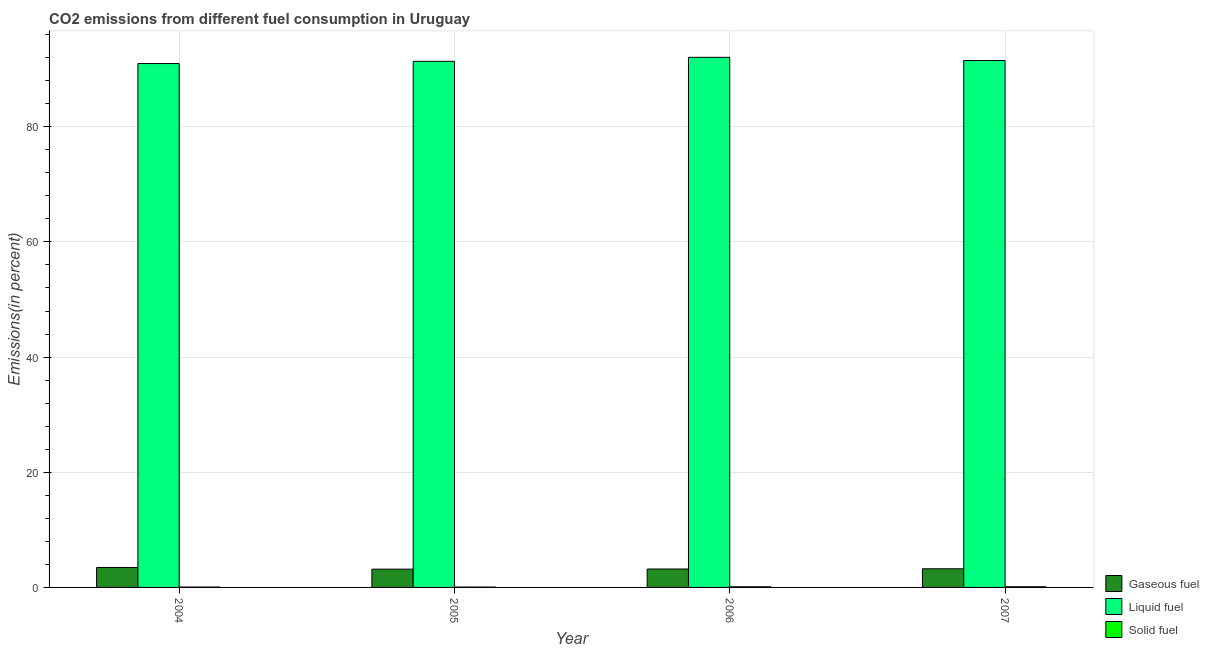How many groups of bars are there?
Offer a very short reply. 4. Are the number of bars per tick equal to the number of legend labels?
Offer a very short reply. Yes. Are the number of bars on each tick of the X-axis equal?
Provide a short and direct response. Yes. How many bars are there on the 1st tick from the right?
Provide a short and direct response. 3. What is the label of the 2nd group of bars from the left?
Your answer should be compact. 2005. In how many cases, is the number of bars for a given year not equal to the number of legend labels?
Offer a very short reply. 0. What is the percentage of gaseous fuel emission in 2007?
Provide a succinct answer. 3.24. Across all years, what is the maximum percentage of solid fuel emission?
Your response must be concise. 0.12. Across all years, what is the minimum percentage of gaseous fuel emission?
Offer a terse response. 3.17. In which year was the percentage of solid fuel emission minimum?
Your response must be concise. 2005. What is the total percentage of solid fuel emission in the graph?
Offer a terse response. 0.36. What is the difference between the percentage of gaseous fuel emission in 2004 and that in 2005?
Provide a succinct answer. 0.29. What is the difference between the percentage of gaseous fuel emission in 2007 and the percentage of solid fuel emission in 2006?
Keep it short and to the point. 0.04. What is the average percentage of liquid fuel emission per year?
Keep it short and to the point. 91.48. In how many years, is the percentage of liquid fuel emission greater than 20 %?
Offer a terse response. 4. What is the ratio of the percentage of liquid fuel emission in 2004 to that in 2006?
Keep it short and to the point. 0.99. Is the percentage of liquid fuel emission in 2004 less than that in 2005?
Offer a very short reply. Yes. Is the difference between the percentage of solid fuel emission in 2005 and 2006 greater than the difference between the percentage of gaseous fuel emission in 2005 and 2006?
Provide a succinct answer. No. What is the difference between the highest and the second highest percentage of gaseous fuel emission?
Your answer should be very brief. 0.22. What is the difference between the highest and the lowest percentage of liquid fuel emission?
Your answer should be compact. 1.08. In how many years, is the percentage of liquid fuel emission greater than the average percentage of liquid fuel emission taken over all years?
Provide a succinct answer. 2. What does the 2nd bar from the left in 2006 represents?
Provide a short and direct response. Liquid fuel. What does the 2nd bar from the right in 2007 represents?
Your answer should be compact. Liquid fuel. Is it the case that in every year, the sum of the percentage of gaseous fuel emission and percentage of liquid fuel emission is greater than the percentage of solid fuel emission?
Ensure brevity in your answer.  Yes. Are all the bars in the graph horizontal?
Offer a terse response. No. Are the values on the major ticks of Y-axis written in scientific E-notation?
Your answer should be very brief. No. Where does the legend appear in the graph?
Give a very brief answer. Bottom right. How many legend labels are there?
Your response must be concise. 3. What is the title of the graph?
Make the answer very short. CO2 emissions from different fuel consumption in Uruguay. Does "Ores and metals" appear as one of the legend labels in the graph?
Give a very brief answer. No. What is the label or title of the Y-axis?
Offer a terse response. Emissions(in percent). What is the Emissions(in percent) in Gaseous fuel in 2004?
Ensure brevity in your answer.  3.46. What is the Emissions(in percent) of Liquid fuel in 2004?
Provide a short and direct response. 90.98. What is the Emissions(in percent) in Solid fuel in 2004?
Make the answer very short. 0.07. What is the Emissions(in percent) of Gaseous fuel in 2005?
Provide a succinct answer. 3.17. What is the Emissions(in percent) of Liquid fuel in 2005?
Give a very brief answer. 91.37. What is the Emissions(in percent) in Solid fuel in 2005?
Give a very brief answer. 0.06. What is the Emissions(in percent) of Gaseous fuel in 2006?
Your answer should be compact. 3.2. What is the Emissions(in percent) in Liquid fuel in 2006?
Provide a short and direct response. 92.06. What is the Emissions(in percent) in Solid fuel in 2006?
Your response must be concise. 0.11. What is the Emissions(in percent) of Gaseous fuel in 2007?
Your response must be concise. 3.24. What is the Emissions(in percent) in Liquid fuel in 2007?
Ensure brevity in your answer.  91.5. What is the Emissions(in percent) of Solid fuel in 2007?
Offer a very short reply. 0.12. Across all years, what is the maximum Emissions(in percent) in Gaseous fuel?
Your answer should be compact. 3.46. Across all years, what is the maximum Emissions(in percent) of Liquid fuel?
Ensure brevity in your answer.  92.06. Across all years, what is the maximum Emissions(in percent) in Solid fuel?
Ensure brevity in your answer.  0.12. Across all years, what is the minimum Emissions(in percent) in Gaseous fuel?
Provide a short and direct response. 3.17. Across all years, what is the minimum Emissions(in percent) of Liquid fuel?
Provide a short and direct response. 90.98. Across all years, what is the minimum Emissions(in percent) of Solid fuel?
Provide a succinct answer. 0.06. What is the total Emissions(in percent) of Gaseous fuel in the graph?
Provide a succinct answer. 13.08. What is the total Emissions(in percent) in Liquid fuel in the graph?
Make the answer very short. 365.91. What is the total Emissions(in percent) in Solid fuel in the graph?
Your answer should be very brief. 0.36. What is the difference between the Emissions(in percent) of Gaseous fuel in 2004 and that in 2005?
Offer a very short reply. 0.29. What is the difference between the Emissions(in percent) of Liquid fuel in 2004 and that in 2005?
Provide a short and direct response. -0.38. What is the difference between the Emissions(in percent) in Solid fuel in 2004 and that in 2005?
Provide a succinct answer. 0. What is the difference between the Emissions(in percent) of Gaseous fuel in 2004 and that in 2006?
Ensure brevity in your answer.  0.26. What is the difference between the Emissions(in percent) of Liquid fuel in 2004 and that in 2006?
Make the answer very short. -1.08. What is the difference between the Emissions(in percent) in Solid fuel in 2004 and that in 2006?
Make the answer very short. -0.04. What is the difference between the Emissions(in percent) of Gaseous fuel in 2004 and that in 2007?
Offer a very short reply. 0.22. What is the difference between the Emissions(in percent) in Liquid fuel in 2004 and that in 2007?
Provide a short and direct response. -0.52. What is the difference between the Emissions(in percent) of Solid fuel in 2004 and that in 2007?
Your answer should be very brief. -0.06. What is the difference between the Emissions(in percent) of Gaseous fuel in 2005 and that in 2006?
Make the answer very short. -0.02. What is the difference between the Emissions(in percent) of Liquid fuel in 2005 and that in 2006?
Your answer should be compact. -0.69. What is the difference between the Emissions(in percent) in Solid fuel in 2005 and that in 2006?
Your answer should be compact. -0.05. What is the difference between the Emissions(in percent) in Gaseous fuel in 2005 and that in 2007?
Ensure brevity in your answer.  -0.07. What is the difference between the Emissions(in percent) in Liquid fuel in 2005 and that in 2007?
Your response must be concise. -0.14. What is the difference between the Emissions(in percent) in Solid fuel in 2005 and that in 2007?
Ensure brevity in your answer.  -0.06. What is the difference between the Emissions(in percent) in Gaseous fuel in 2006 and that in 2007?
Provide a short and direct response. -0.04. What is the difference between the Emissions(in percent) of Liquid fuel in 2006 and that in 2007?
Give a very brief answer. 0.55. What is the difference between the Emissions(in percent) of Solid fuel in 2006 and that in 2007?
Make the answer very short. -0.01. What is the difference between the Emissions(in percent) of Gaseous fuel in 2004 and the Emissions(in percent) of Liquid fuel in 2005?
Provide a short and direct response. -87.9. What is the difference between the Emissions(in percent) in Gaseous fuel in 2004 and the Emissions(in percent) in Solid fuel in 2005?
Give a very brief answer. 3.4. What is the difference between the Emissions(in percent) in Liquid fuel in 2004 and the Emissions(in percent) in Solid fuel in 2005?
Offer a very short reply. 90.92. What is the difference between the Emissions(in percent) in Gaseous fuel in 2004 and the Emissions(in percent) in Liquid fuel in 2006?
Your response must be concise. -88.59. What is the difference between the Emissions(in percent) of Gaseous fuel in 2004 and the Emissions(in percent) of Solid fuel in 2006?
Give a very brief answer. 3.35. What is the difference between the Emissions(in percent) in Liquid fuel in 2004 and the Emissions(in percent) in Solid fuel in 2006?
Give a very brief answer. 90.87. What is the difference between the Emissions(in percent) in Gaseous fuel in 2004 and the Emissions(in percent) in Liquid fuel in 2007?
Provide a succinct answer. -88.04. What is the difference between the Emissions(in percent) in Gaseous fuel in 2004 and the Emissions(in percent) in Solid fuel in 2007?
Provide a succinct answer. 3.34. What is the difference between the Emissions(in percent) in Liquid fuel in 2004 and the Emissions(in percent) in Solid fuel in 2007?
Provide a succinct answer. 90.86. What is the difference between the Emissions(in percent) of Gaseous fuel in 2005 and the Emissions(in percent) of Liquid fuel in 2006?
Ensure brevity in your answer.  -88.88. What is the difference between the Emissions(in percent) of Gaseous fuel in 2005 and the Emissions(in percent) of Solid fuel in 2006?
Offer a terse response. 3.06. What is the difference between the Emissions(in percent) in Liquid fuel in 2005 and the Emissions(in percent) in Solid fuel in 2006?
Keep it short and to the point. 91.25. What is the difference between the Emissions(in percent) in Gaseous fuel in 2005 and the Emissions(in percent) in Liquid fuel in 2007?
Your answer should be compact. -88.33. What is the difference between the Emissions(in percent) of Gaseous fuel in 2005 and the Emissions(in percent) of Solid fuel in 2007?
Offer a terse response. 3.05. What is the difference between the Emissions(in percent) of Liquid fuel in 2005 and the Emissions(in percent) of Solid fuel in 2007?
Your response must be concise. 91.24. What is the difference between the Emissions(in percent) of Gaseous fuel in 2006 and the Emissions(in percent) of Liquid fuel in 2007?
Make the answer very short. -88.3. What is the difference between the Emissions(in percent) in Gaseous fuel in 2006 and the Emissions(in percent) in Solid fuel in 2007?
Your response must be concise. 3.08. What is the difference between the Emissions(in percent) of Liquid fuel in 2006 and the Emissions(in percent) of Solid fuel in 2007?
Your response must be concise. 91.94. What is the average Emissions(in percent) in Gaseous fuel per year?
Offer a very short reply. 3.27. What is the average Emissions(in percent) of Liquid fuel per year?
Ensure brevity in your answer.  91.48. What is the average Emissions(in percent) of Solid fuel per year?
Give a very brief answer. 0.09. In the year 2004, what is the difference between the Emissions(in percent) of Gaseous fuel and Emissions(in percent) of Liquid fuel?
Offer a terse response. -87.52. In the year 2004, what is the difference between the Emissions(in percent) of Gaseous fuel and Emissions(in percent) of Solid fuel?
Offer a very short reply. 3.4. In the year 2004, what is the difference between the Emissions(in percent) in Liquid fuel and Emissions(in percent) in Solid fuel?
Give a very brief answer. 90.92. In the year 2005, what is the difference between the Emissions(in percent) in Gaseous fuel and Emissions(in percent) in Liquid fuel?
Provide a succinct answer. -88.19. In the year 2005, what is the difference between the Emissions(in percent) of Gaseous fuel and Emissions(in percent) of Solid fuel?
Your answer should be very brief. 3.11. In the year 2005, what is the difference between the Emissions(in percent) in Liquid fuel and Emissions(in percent) in Solid fuel?
Your answer should be compact. 91.3. In the year 2006, what is the difference between the Emissions(in percent) of Gaseous fuel and Emissions(in percent) of Liquid fuel?
Offer a very short reply. -88.86. In the year 2006, what is the difference between the Emissions(in percent) of Gaseous fuel and Emissions(in percent) of Solid fuel?
Make the answer very short. 3.09. In the year 2006, what is the difference between the Emissions(in percent) of Liquid fuel and Emissions(in percent) of Solid fuel?
Keep it short and to the point. 91.95. In the year 2007, what is the difference between the Emissions(in percent) in Gaseous fuel and Emissions(in percent) in Liquid fuel?
Offer a terse response. -88.26. In the year 2007, what is the difference between the Emissions(in percent) in Gaseous fuel and Emissions(in percent) in Solid fuel?
Keep it short and to the point. 3.12. In the year 2007, what is the difference between the Emissions(in percent) in Liquid fuel and Emissions(in percent) in Solid fuel?
Make the answer very short. 91.38. What is the ratio of the Emissions(in percent) of Gaseous fuel in 2004 to that in 2005?
Offer a terse response. 1.09. What is the ratio of the Emissions(in percent) of Liquid fuel in 2004 to that in 2005?
Give a very brief answer. 1. What is the ratio of the Emissions(in percent) of Solid fuel in 2004 to that in 2005?
Your response must be concise. 1.03. What is the ratio of the Emissions(in percent) of Gaseous fuel in 2004 to that in 2006?
Offer a terse response. 1.08. What is the ratio of the Emissions(in percent) of Liquid fuel in 2004 to that in 2006?
Provide a succinct answer. 0.99. What is the ratio of the Emissions(in percent) of Solid fuel in 2004 to that in 2006?
Ensure brevity in your answer.  0.59. What is the ratio of the Emissions(in percent) in Gaseous fuel in 2004 to that in 2007?
Keep it short and to the point. 1.07. What is the ratio of the Emissions(in percent) in Solid fuel in 2004 to that in 2007?
Offer a very short reply. 0.53. What is the ratio of the Emissions(in percent) of Gaseous fuel in 2005 to that in 2006?
Offer a very short reply. 0.99. What is the ratio of the Emissions(in percent) of Solid fuel in 2005 to that in 2006?
Offer a very short reply. 0.58. What is the ratio of the Emissions(in percent) in Gaseous fuel in 2005 to that in 2007?
Keep it short and to the point. 0.98. What is the ratio of the Emissions(in percent) of Solid fuel in 2005 to that in 2007?
Provide a short and direct response. 0.52. What is the ratio of the Emissions(in percent) in Gaseous fuel in 2006 to that in 2007?
Offer a very short reply. 0.99. What is the ratio of the Emissions(in percent) of Liquid fuel in 2006 to that in 2007?
Your answer should be compact. 1.01. What is the ratio of the Emissions(in percent) of Solid fuel in 2006 to that in 2007?
Offer a very short reply. 0.9. What is the difference between the highest and the second highest Emissions(in percent) of Gaseous fuel?
Your answer should be very brief. 0.22. What is the difference between the highest and the second highest Emissions(in percent) in Liquid fuel?
Your answer should be compact. 0.55. What is the difference between the highest and the second highest Emissions(in percent) in Solid fuel?
Provide a short and direct response. 0.01. What is the difference between the highest and the lowest Emissions(in percent) in Gaseous fuel?
Ensure brevity in your answer.  0.29. What is the difference between the highest and the lowest Emissions(in percent) of Liquid fuel?
Provide a short and direct response. 1.08. What is the difference between the highest and the lowest Emissions(in percent) in Solid fuel?
Provide a short and direct response. 0.06. 